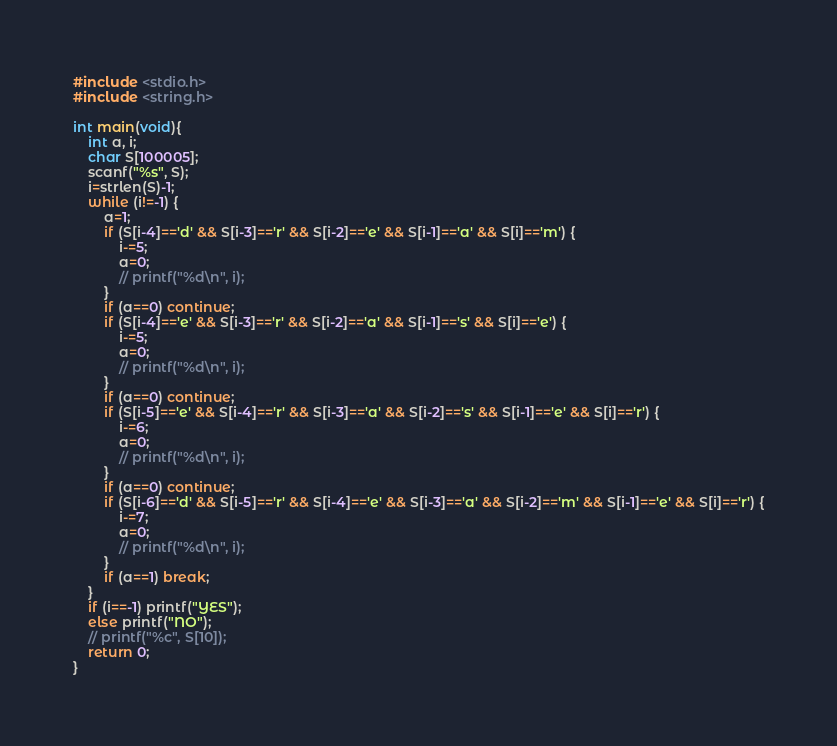Convert code to text. <code><loc_0><loc_0><loc_500><loc_500><_C_>#include <stdio.h>
#include <string.h>

int main(void){
    int a, i;
    char S[100005];
    scanf("%s", S);
    i=strlen(S)-1;
    while (i!=-1) {
        a=1;
        if (S[i-4]=='d' && S[i-3]=='r' && S[i-2]=='e' && S[i-1]=='a' && S[i]=='m') {
            i-=5;
            a=0;
            // printf("%d\n", i);
        }
        if (a==0) continue;
        if (S[i-4]=='e' && S[i-3]=='r' && S[i-2]=='a' && S[i-1]=='s' && S[i]=='e') {
            i-=5;
            a=0;
            // printf("%d\n", i);
        }
        if (a==0) continue;
        if (S[i-5]=='e' && S[i-4]=='r' && S[i-3]=='a' && S[i-2]=='s' && S[i-1]=='e' && S[i]=='r') {
            i-=6;
            a=0;
            // printf("%d\n", i);
        }
        if (a==0) continue;
        if (S[i-6]=='d' && S[i-5]=='r' && S[i-4]=='e' && S[i-3]=='a' && S[i-2]=='m' && S[i-1]=='e' && S[i]=='r') {
            i-=7;
            a=0;
            // printf("%d\n", i);
        }
        if (a==1) break;
    }
    if (i==-1) printf("YES");
    else printf("NO");
    // printf("%c", S[10]);
    return 0;
}</code> 